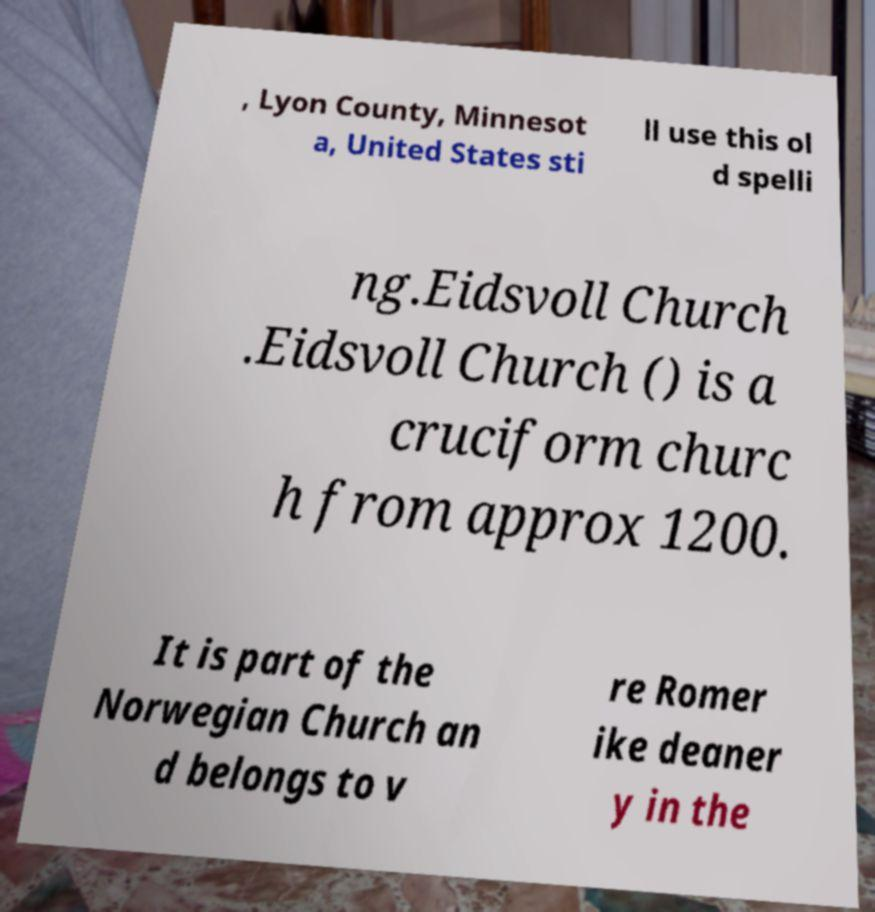Please identify and transcribe the text found in this image. , Lyon County, Minnesot a, United States sti ll use this ol d spelli ng.Eidsvoll Church .Eidsvoll Church () is a cruciform churc h from approx 1200. It is part of the Norwegian Church an d belongs to v re Romer ike deaner y in the 